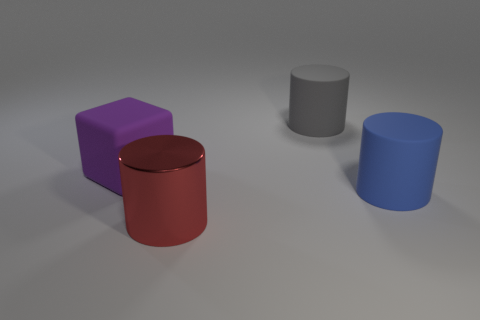Can you tell me the colors of the objects and describe the light in the scene? The objects present are of various colors: a purple cube, a red cylinder with a reflective surface, a grey cylinder, and a blue cylinder with a matte finish. The lighting in the scene is soft and diffused, creating gentle shadows and highlights on the objects, indicating what may be either a cloudy day or an indoor environment with well-diffused ambient lighting. 